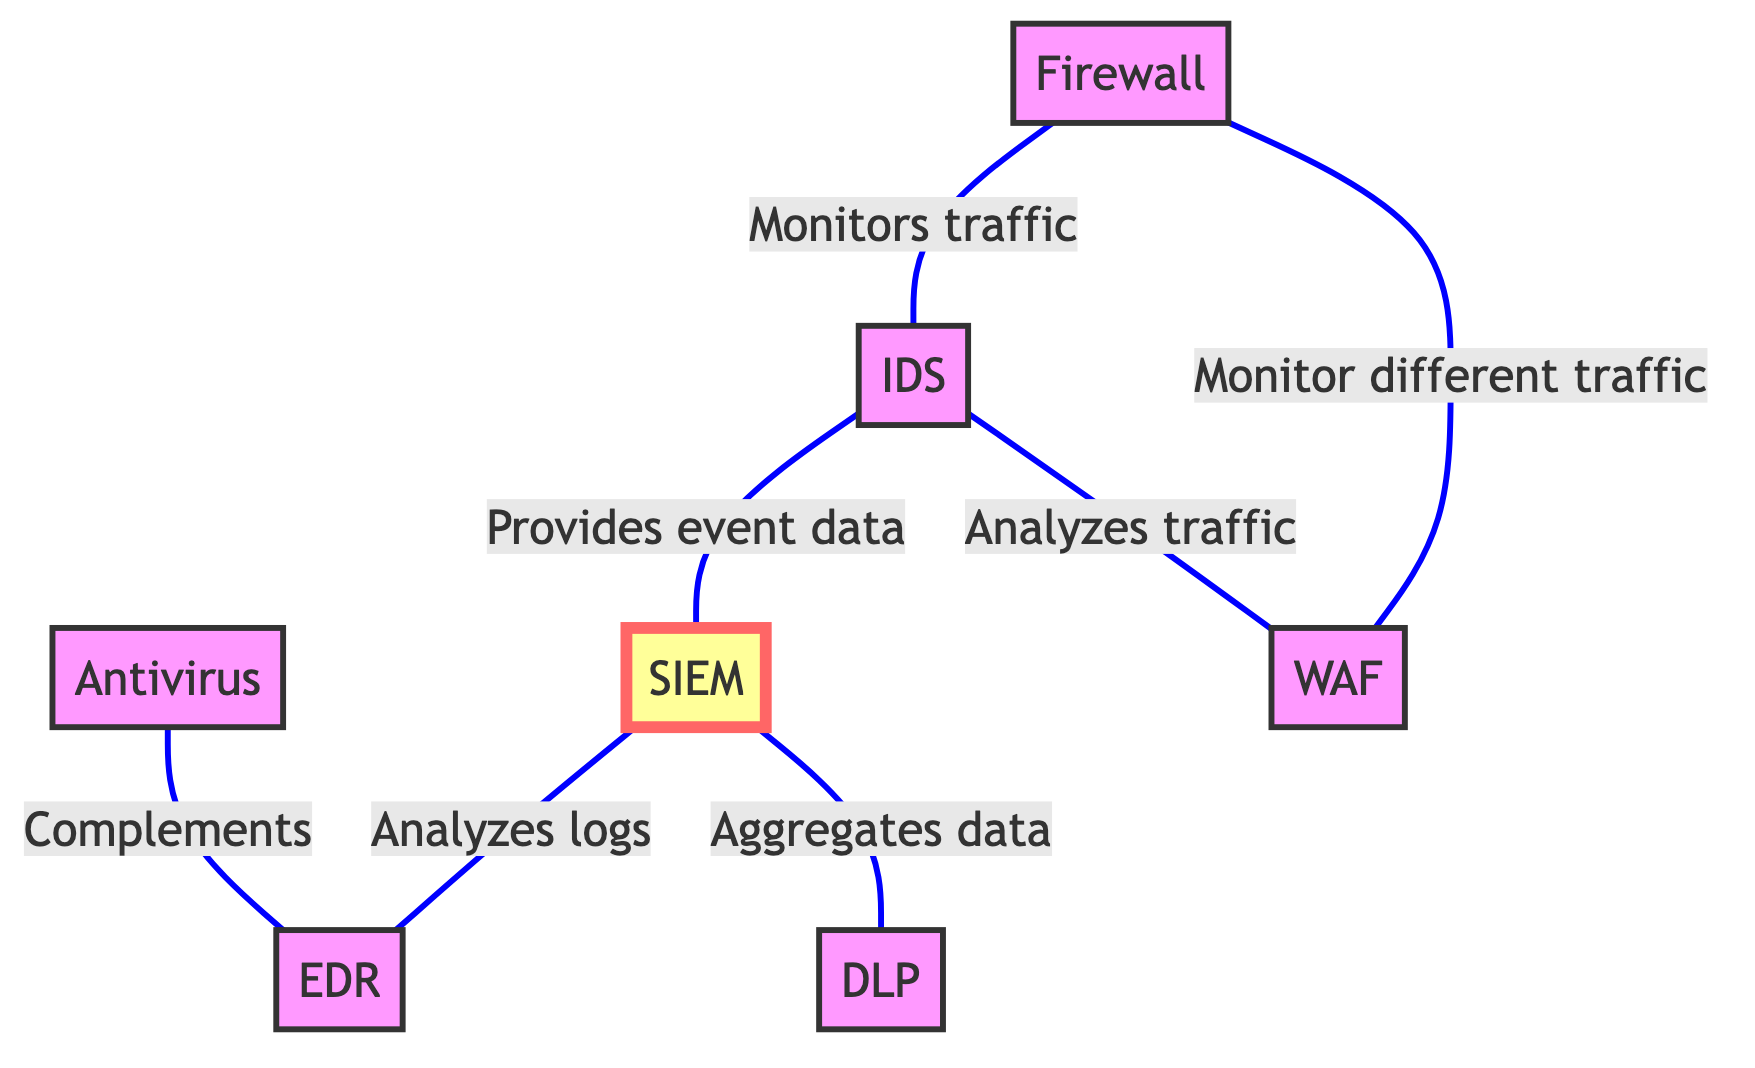What is the total number of nodes in the diagram? The diagram lists seven distinct security tools, which are represented as nodes. By counting these, we find that the total number of nodes is seven.
Answer: 7 Which security tool is monitored by the Firewall? The Firewall monitors traffic, and it has a direct connection to the Intrusion Detection System (IDS), indicating that the IDS is the tool being monitored.
Answer: IDS What type of data does the IDS provide to SIEM? According to the diagram, the IDS provides event data to the SIEM for correlation and analysis, which can be directly referenced from the edge connecting these two nodes.
Answer: Event data Which two tools complement each other in malware detection? The diagram indicates that the Antivirus Software works in conjunction with the Endpoint Detection and Response tool for malware detection and response. This can be traced through the direct connection between them.
Answer: Antivirus Software and EDR What is the role of SIEM in relation to DLP? The SIEM aggregates data for analysis, including incident data from the Data Loss Prevention (DLP) tool. This relationship can be observed from the edge connecting the SIEM to the DLP node.
Answer: Aggregates data How many unique connections are there between the tools illustrated in the diagram? By counting the edges that connect different nodes, we find that there are six unique connections between the various security tools, as indicated in the edges section of the diagram.
Answer: 6 Which tool analyzes traffic that passes through the WAF? The IDS analyzes the traffic that passes through the Web Application Firewall (WAF), which is directly stated by the edge connecting these two nodes in the diagram.
Answer: IDS What do the Firewall and WAF have in common? Both the Firewall and WAF monitor and filter different types of network traffic, as is shown by the direct connection in the diagram indicating their overlap in functionality.
Answer: Monitor and filter network traffic 